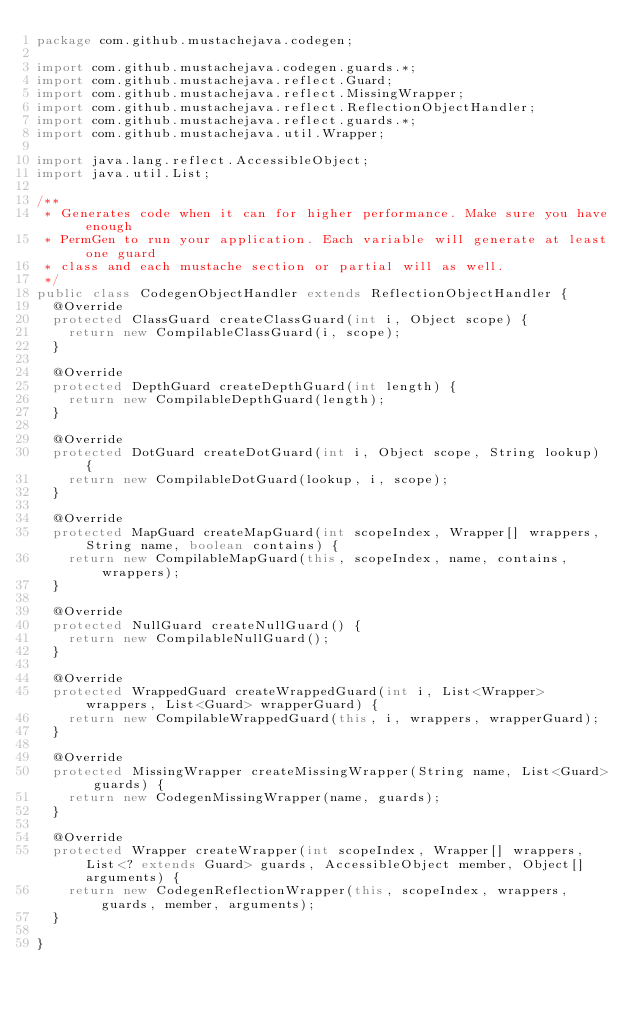Convert code to text. <code><loc_0><loc_0><loc_500><loc_500><_Java_>package com.github.mustachejava.codegen;

import com.github.mustachejava.codegen.guards.*;
import com.github.mustachejava.reflect.Guard;
import com.github.mustachejava.reflect.MissingWrapper;
import com.github.mustachejava.reflect.ReflectionObjectHandler;
import com.github.mustachejava.reflect.guards.*;
import com.github.mustachejava.util.Wrapper;

import java.lang.reflect.AccessibleObject;
import java.util.List;

/**
 * Generates code when it can for higher performance. Make sure you have enough
 * PermGen to run your application. Each variable will generate at least one guard
 * class and each mustache section or partial will as well.
 */
public class CodegenObjectHandler extends ReflectionObjectHandler {
  @Override
  protected ClassGuard createClassGuard(int i, Object scope) {
    return new CompilableClassGuard(i, scope);
  }

  @Override
  protected DepthGuard createDepthGuard(int length) {
    return new CompilableDepthGuard(length);
  }

  @Override
  protected DotGuard createDotGuard(int i, Object scope, String lookup) {
    return new CompilableDotGuard(lookup, i, scope);
  }

  @Override
  protected MapGuard createMapGuard(int scopeIndex, Wrapper[] wrappers, String name, boolean contains) {
    return new CompilableMapGuard(this, scopeIndex, name, contains, wrappers);
  }

  @Override
  protected NullGuard createNullGuard() {
    return new CompilableNullGuard();
  }

  @Override
  protected WrappedGuard createWrappedGuard(int i, List<Wrapper> wrappers, List<Guard> wrapperGuard) {
    return new CompilableWrappedGuard(this, i, wrappers, wrapperGuard);
  }

  @Override
  protected MissingWrapper createMissingWrapper(String name, List<Guard> guards) {
    return new CodegenMissingWrapper(name, guards);
  }

  @Override
  protected Wrapper createWrapper(int scopeIndex, Wrapper[] wrappers, List<? extends Guard> guards, AccessibleObject member, Object[] arguments) {
    return new CodegenReflectionWrapper(this, scopeIndex, wrappers, guards, member, arguments);
  }

}
</code> 